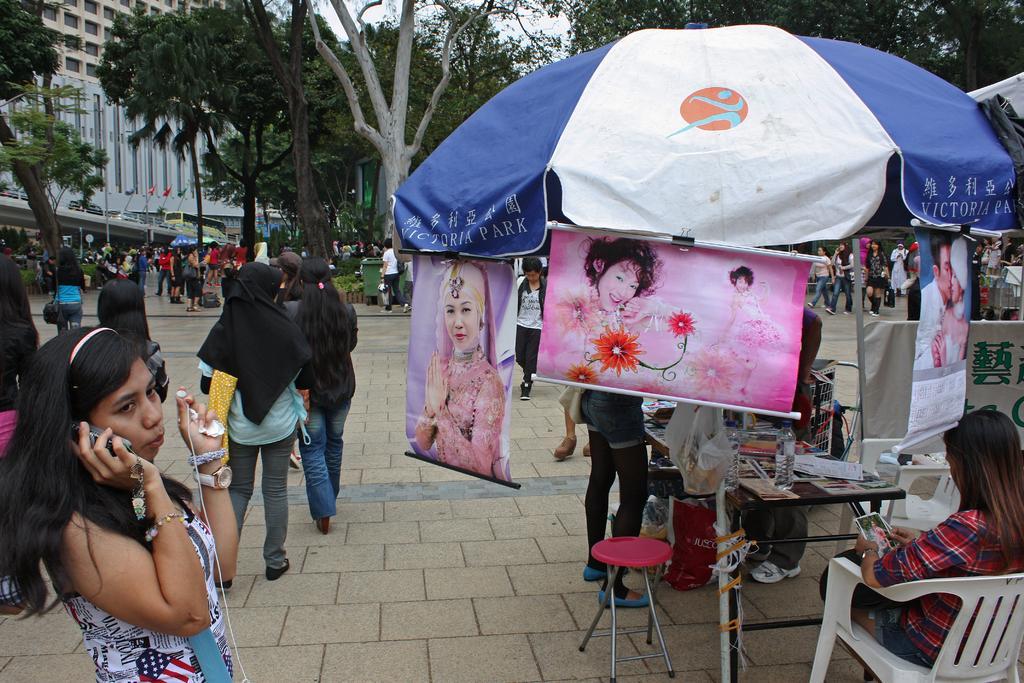Describe this image in one or two sentences. In the center of the image we can see people standing and walking. In the background there are trees and buildings. On the right there is a parasol and a table. We can see a lady sitting. There are boards. 